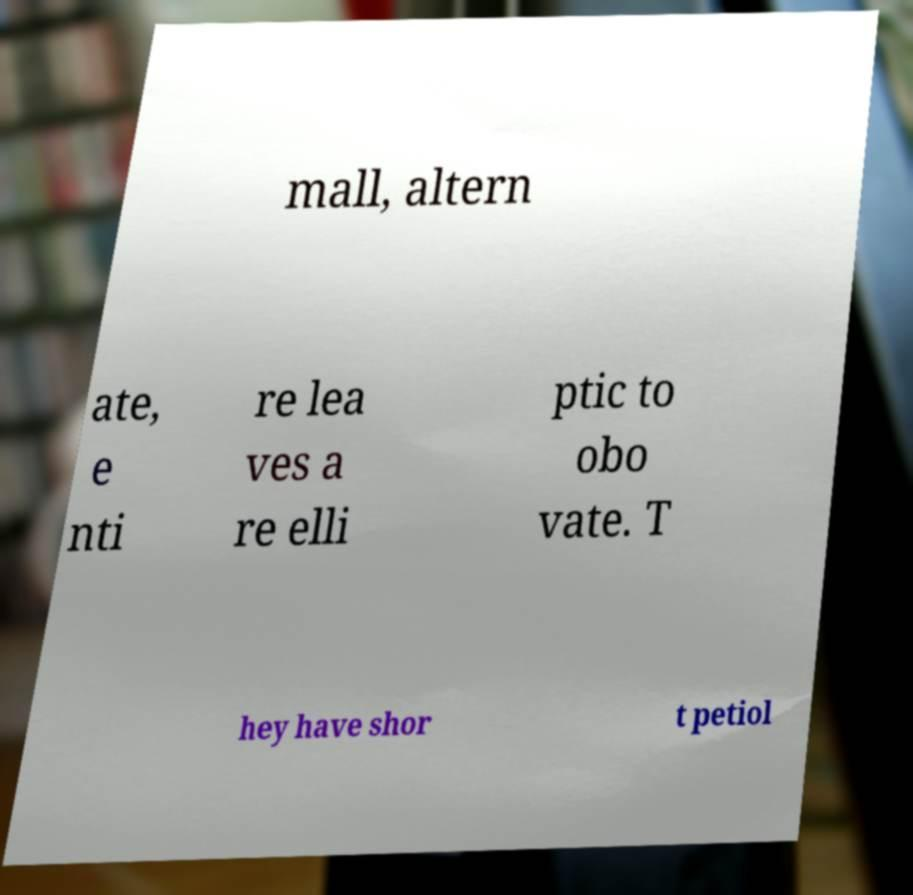Please read and relay the text visible in this image. What does it say? mall, altern ate, e nti re lea ves a re elli ptic to obo vate. T hey have shor t petiol 